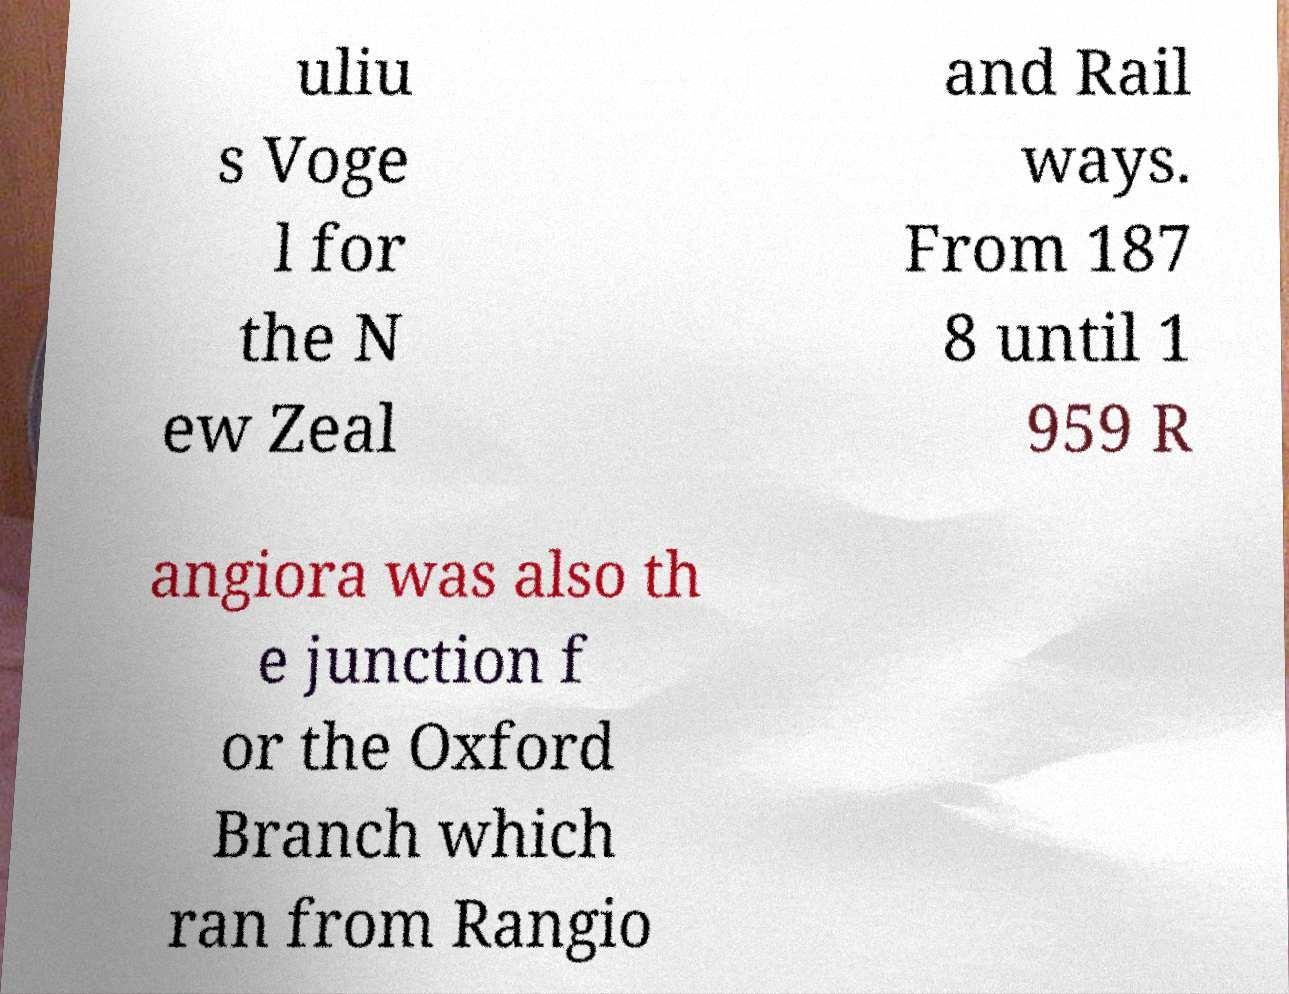There's text embedded in this image that I need extracted. Can you transcribe it verbatim? uliu s Voge l for the N ew Zeal and Rail ways. From 187 8 until 1 959 R angiora was also th e junction f or the Oxford Branch which ran from Rangio 